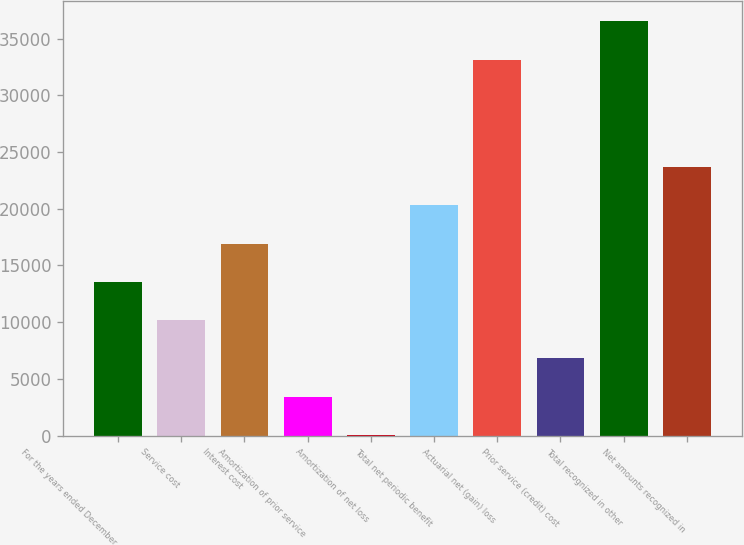Convert chart. <chart><loc_0><loc_0><loc_500><loc_500><bar_chart><fcel>For the years ended December<fcel>Service cost<fcel>Interest cost<fcel>Amortization of prior service<fcel>Amortization of net loss<fcel>Total net periodic benefit<fcel>Actuarial net (gain) loss<fcel>Prior service (credit) cost<fcel>Total recognized in other<fcel>Net amounts recognized in<nl><fcel>13562.6<fcel>10190.2<fcel>16935<fcel>3445.4<fcel>73<fcel>20307.4<fcel>33165<fcel>6817.8<fcel>36537.4<fcel>23679.8<nl></chart> 